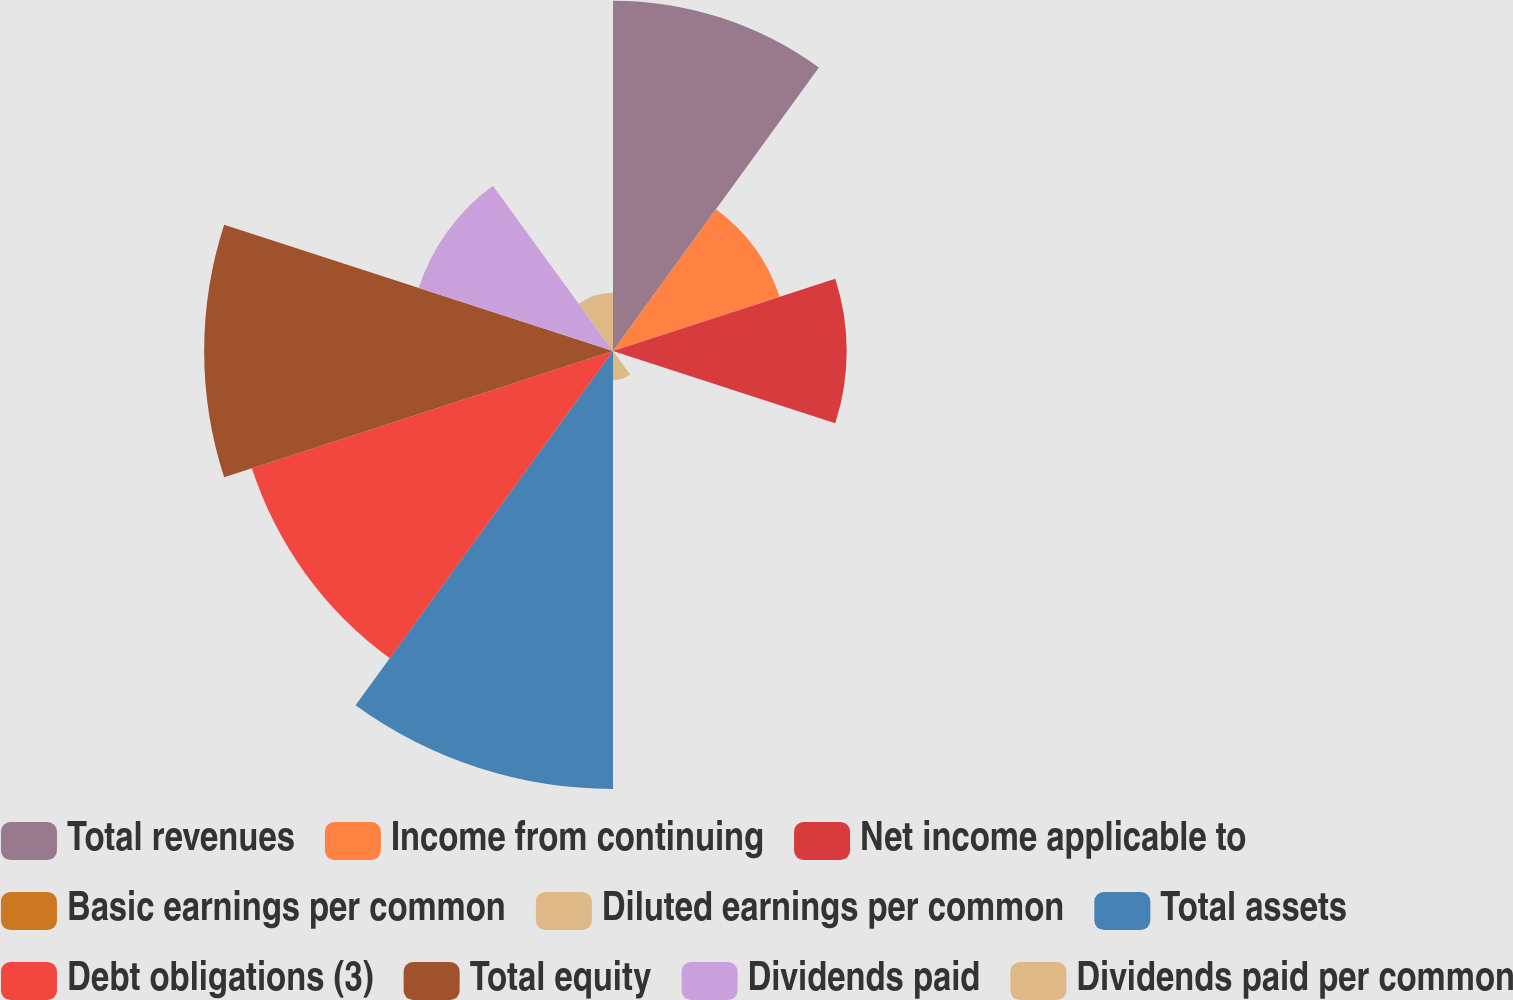Convert chart to OTSL. <chart><loc_0><loc_0><loc_500><loc_500><pie_chart><fcel>Total revenues<fcel>Income from continuing<fcel>Net income applicable to<fcel>Basic earnings per common<fcel>Diluted earnings per common<fcel>Total assets<fcel>Debt obligations (3)<fcel>Total equity<fcel>Dividends paid<fcel>Dividends paid per common<nl><fcel>15.38%<fcel>7.69%<fcel>10.26%<fcel>0.0%<fcel>1.28%<fcel>19.23%<fcel>16.67%<fcel>17.95%<fcel>8.97%<fcel>2.56%<nl></chart> 